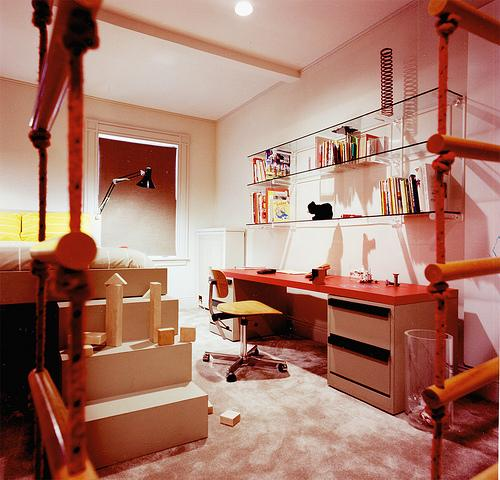Who uses this room? Please explain your reasoning. child. The childrens toys and ladders tell us this is a young person's room. 